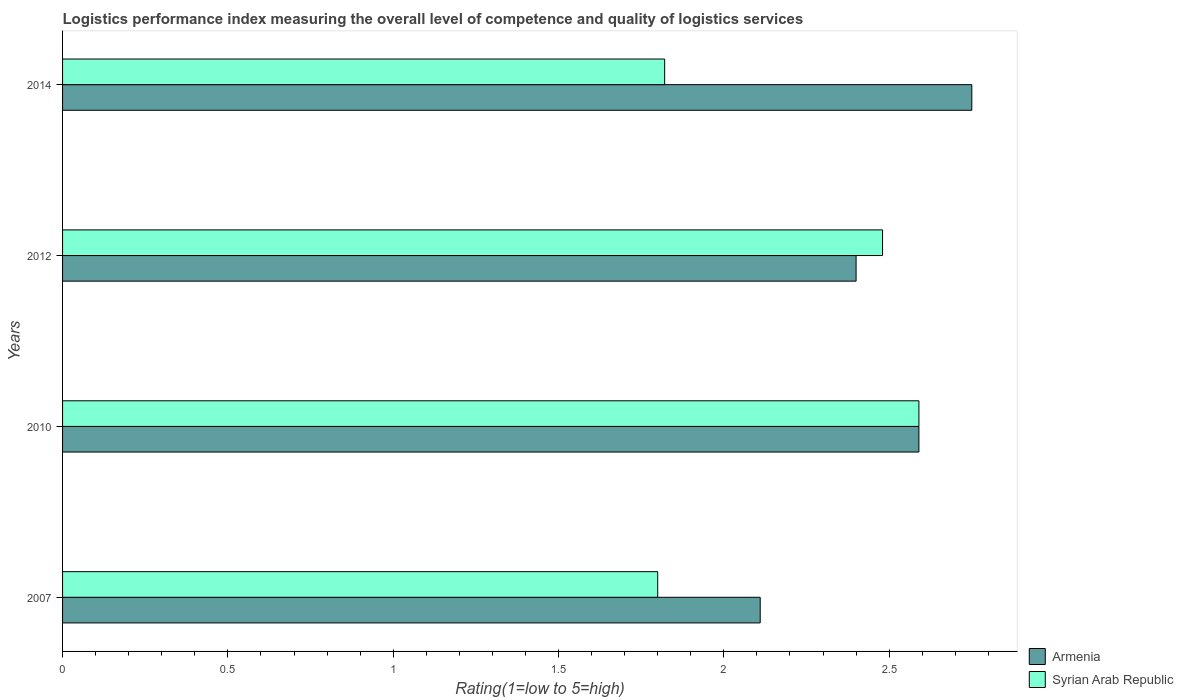How many different coloured bars are there?
Provide a succinct answer. 2. Are the number of bars on each tick of the Y-axis equal?
Keep it short and to the point. Yes. How many bars are there on the 1st tick from the top?
Your answer should be compact. 2. In how many cases, is the number of bars for a given year not equal to the number of legend labels?
Your answer should be compact. 0. What is the Logistic performance index in Armenia in 2014?
Keep it short and to the point. 2.75. Across all years, what is the maximum Logistic performance index in Armenia?
Your answer should be very brief. 2.75. Across all years, what is the minimum Logistic performance index in Armenia?
Offer a very short reply. 2.11. What is the total Logistic performance index in Syrian Arab Republic in the graph?
Provide a succinct answer. 8.69. What is the difference between the Logistic performance index in Armenia in 2012 and that in 2014?
Ensure brevity in your answer.  -0.35. What is the difference between the Logistic performance index in Syrian Arab Republic in 2010 and the Logistic performance index in Armenia in 2014?
Offer a terse response. -0.16. What is the average Logistic performance index in Syrian Arab Republic per year?
Your answer should be very brief. 2.17. In the year 2012, what is the difference between the Logistic performance index in Syrian Arab Republic and Logistic performance index in Armenia?
Offer a terse response. 0.08. What is the ratio of the Logistic performance index in Syrian Arab Republic in 2007 to that in 2014?
Keep it short and to the point. 0.99. What is the difference between the highest and the second highest Logistic performance index in Syrian Arab Republic?
Your answer should be compact. 0.11. What is the difference between the highest and the lowest Logistic performance index in Armenia?
Give a very brief answer. 0.64. What does the 2nd bar from the top in 2014 represents?
Provide a succinct answer. Armenia. What does the 2nd bar from the bottom in 2010 represents?
Offer a very short reply. Syrian Arab Republic. Are all the bars in the graph horizontal?
Your response must be concise. Yes. How many years are there in the graph?
Ensure brevity in your answer.  4. Are the values on the major ticks of X-axis written in scientific E-notation?
Offer a terse response. No. Does the graph contain any zero values?
Your response must be concise. No. Where does the legend appear in the graph?
Offer a very short reply. Bottom right. What is the title of the graph?
Your answer should be very brief. Logistics performance index measuring the overall level of competence and quality of logistics services. Does "Costa Rica" appear as one of the legend labels in the graph?
Keep it short and to the point. No. What is the label or title of the X-axis?
Provide a succinct answer. Rating(1=low to 5=high). What is the Rating(1=low to 5=high) of Armenia in 2007?
Give a very brief answer. 2.11. What is the Rating(1=low to 5=high) of Armenia in 2010?
Provide a short and direct response. 2.59. What is the Rating(1=low to 5=high) in Syrian Arab Republic in 2010?
Offer a very short reply. 2.59. What is the Rating(1=low to 5=high) of Syrian Arab Republic in 2012?
Offer a terse response. 2.48. What is the Rating(1=low to 5=high) in Armenia in 2014?
Provide a succinct answer. 2.75. What is the Rating(1=low to 5=high) of Syrian Arab Republic in 2014?
Offer a terse response. 1.82. Across all years, what is the maximum Rating(1=low to 5=high) in Armenia?
Offer a very short reply. 2.75. Across all years, what is the maximum Rating(1=low to 5=high) of Syrian Arab Republic?
Provide a short and direct response. 2.59. Across all years, what is the minimum Rating(1=low to 5=high) in Armenia?
Ensure brevity in your answer.  2.11. Across all years, what is the minimum Rating(1=low to 5=high) in Syrian Arab Republic?
Ensure brevity in your answer.  1.8. What is the total Rating(1=low to 5=high) of Armenia in the graph?
Keep it short and to the point. 9.85. What is the total Rating(1=low to 5=high) of Syrian Arab Republic in the graph?
Ensure brevity in your answer.  8.69. What is the difference between the Rating(1=low to 5=high) in Armenia in 2007 and that in 2010?
Keep it short and to the point. -0.48. What is the difference between the Rating(1=low to 5=high) in Syrian Arab Republic in 2007 and that in 2010?
Give a very brief answer. -0.79. What is the difference between the Rating(1=low to 5=high) in Armenia in 2007 and that in 2012?
Ensure brevity in your answer.  -0.29. What is the difference between the Rating(1=low to 5=high) in Syrian Arab Republic in 2007 and that in 2012?
Ensure brevity in your answer.  -0.68. What is the difference between the Rating(1=low to 5=high) of Armenia in 2007 and that in 2014?
Keep it short and to the point. -0.64. What is the difference between the Rating(1=low to 5=high) of Syrian Arab Republic in 2007 and that in 2014?
Provide a short and direct response. -0.02. What is the difference between the Rating(1=low to 5=high) of Armenia in 2010 and that in 2012?
Offer a very short reply. 0.19. What is the difference between the Rating(1=low to 5=high) in Syrian Arab Republic in 2010 and that in 2012?
Your answer should be compact. 0.11. What is the difference between the Rating(1=low to 5=high) of Armenia in 2010 and that in 2014?
Your response must be concise. -0.16. What is the difference between the Rating(1=low to 5=high) of Syrian Arab Republic in 2010 and that in 2014?
Make the answer very short. 0.77. What is the difference between the Rating(1=low to 5=high) in Armenia in 2012 and that in 2014?
Provide a succinct answer. -0.35. What is the difference between the Rating(1=low to 5=high) in Syrian Arab Republic in 2012 and that in 2014?
Ensure brevity in your answer.  0.66. What is the difference between the Rating(1=low to 5=high) of Armenia in 2007 and the Rating(1=low to 5=high) of Syrian Arab Republic in 2010?
Give a very brief answer. -0.48. What is the difference between the Rating(1=low to 5=high) of Armenia in 2007 and the Rating(1=low to 5=high) of Syrian Arab Republic in 2012?
Your response must be concise. -0.37. What is the difference between the Rating(1=low to 5=high) in Armenia in 2007 and the Rating(1=low to 5=high) in Syrian Arab Republic in 2014?
Offer a terse response. 0.29. What is the difference between the Rating(1=low to 5=high) of Armenia in 2010 and the Rating(1=low to 5=high) of Syrian Arab Republic in 2012?
Your answer should be compact. 0.11. What is the difference between the Rating(1=low to 5=high) in Armenia in 2010 and the Rating(1=low to 5=high) in Syrian Arab Republic in 2014?
Give a very brief answer. 0.77. What is the difference between the Rating(1=low to 5=high) in Armenia in 2012 and the Rating(1=low to 5=high) in Syrian Arab Republic in 2014?
Keep it short and to the point. 0.58. What is the average Rating(1=low to 5=high) of Armenia per year?
Provide a succinct answer. 2.46. What is the average Rating(1=low to 5=high) in Syrian Arab Republic per year?
Make the answer very short. 2.17. In the year 2007, what is the difference between the Rating(1=low to 5=high) in Armenia and Rating(1=low to 5=high) in Syrian Arab Republic?
Provide a succinct answer. 0.31. In the year 2010, what is the difference between the Rating(1=low to 5=high) of Armenia and Rating(1=low to 5=high) of Syrian Arab Republic?
Your answer should be compact. 0. In the year 2012, what is the difference between the Rating(1=low to 5=high) in Armenia and Rating(1=low to 5=high) in Syrian Arab Republic?
Give a very brief answer. -0.08. In the year 2014, what is the difference between the Rating(1=low to 5=high) in Armenia and Rating(1=low to 5=high) in Syrian Arab Republic?
Make the answer very short. 0.93. What is the ratio of the Rating(1=low to 5=high) in Armenia in 2007 to that in 2010?
Offer a terse response. 0.81. What is the ratio of the Rating(1=low to 5=high) in Syrian Arab Republic in 2007 to that in 2010?
Your response must be concise. 0.69. What is the ratio of the Rating(1=low to 5=high) in Armenia in 2007 to that in 2012?
Give a very brief answer. 0.88. What is the ratio of the Rating(1=low to 5=high) of Syrian Arab Republic in 2007 to that in 2012?
Your answer should be compact. 0.73. What is the ratio of the Rating(1=low to 5=high) in Armenia in 2007 to that in 2014?
Offer a terse response. 0.77. What is the ratio of the Rating(1=low to 5=high) of Syrian Arab Republic in 2007 to that in 2014?
Your response must be concise. 0.99. What is the ratio of the Rating(1=low to 5=high) in Armenia in 2010 to that in 2012?
Ensure brevity in your answer.  1.08. What is the ratio of the Rating(1=low to 5=high) in Syrian Arab Republic in 2010 to that in 2012?
Offer a terse response. 1.04. What is the ratio of the Rating(1=low to 5=high) in Armenia in 2010 to that in 2014?
Offer a very short reply. 0.94. What is the ratio of the Rating(1=low to 5=high) in Syrian Arab Republic in 2010 to that in 2014?
Your answer should be compact. 1.42. What is the ratio of the Rating(1=low to 5=high) of Armenia in 2012 to that in 2014?
Your response must be concise. 0.87. What is the ratio of the Rating(1=low to 5=high) in Syrian Arab Republic in 2012 to that in 2014?
Keep it short and to the point. 1.36. What is the difference between the highest and the second highest Rating(1=low to 5=high) in Armenia?
Offer a very short reply. 0.16. What is the difference between the highest and the second highest Rating(1=low to 5=high) in Syrian Arab Republic?
Provide a succinct answer. 0.11. What is the difference between the highest and the lowest Rating(1=low to 5=high) of Armenia?
Offer a very short reply. 0.64. What is the difference between the highest and the lowest Rating(1=low to 5=high) of Syrian Arab Republic?
Make the answer very short. 0.79. 